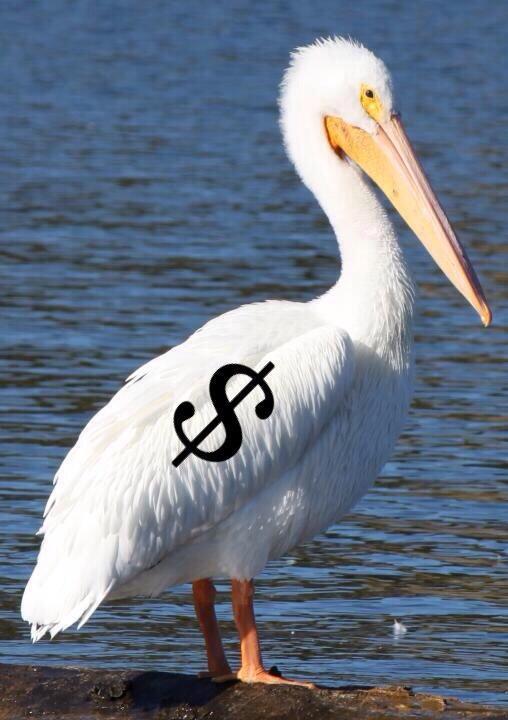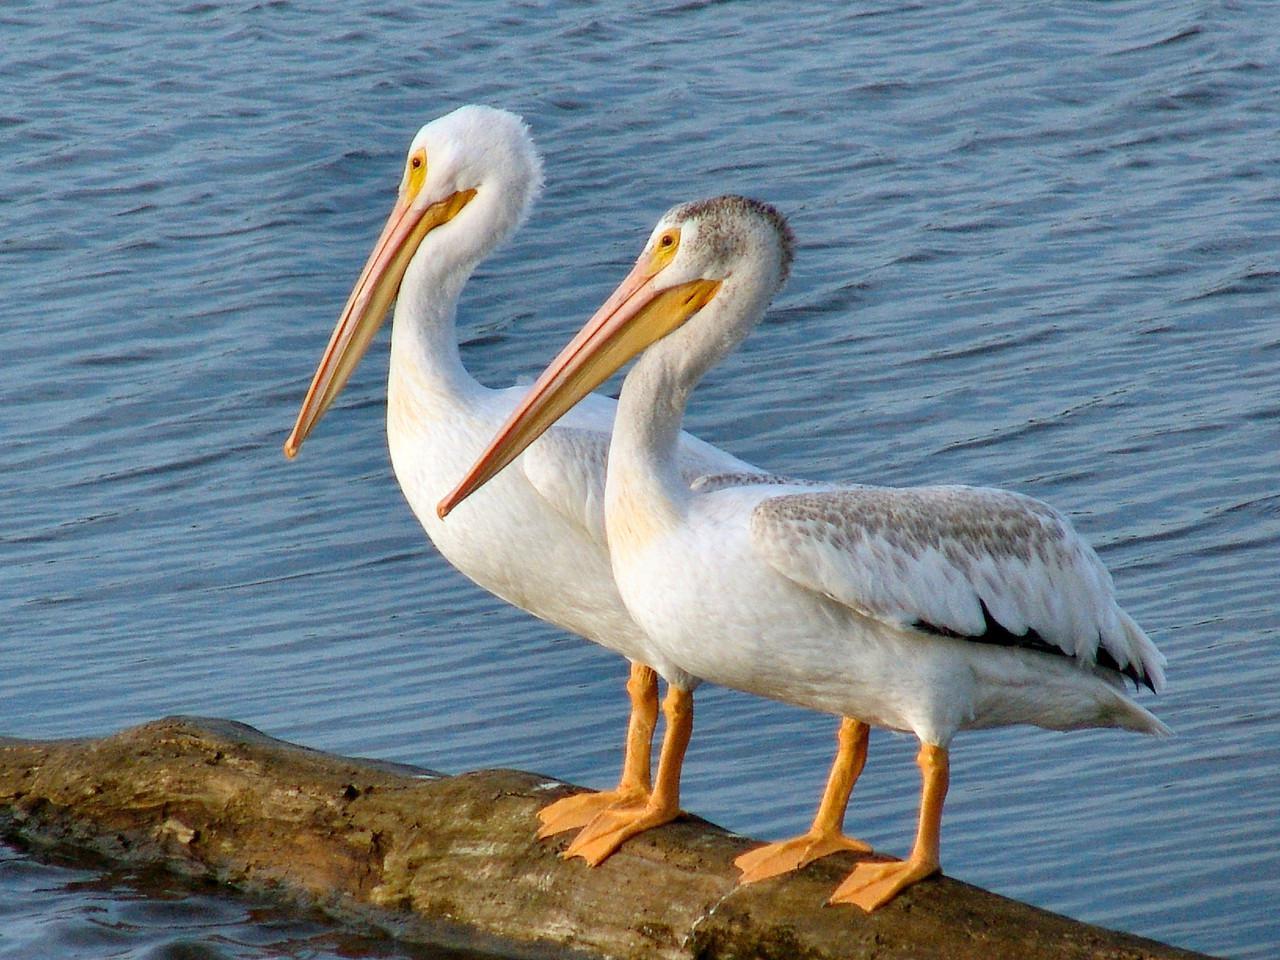The first image is the image on the left, the second image is the image on the right. Assess this claim about the two images: "In one of the image two birds are on a log facing left.". Correct or not? Answer yes or no. Yes. The first image is the image on the left, the second image is the image on the right. Considering the images on both sides, is "One of the pelicans has a fish in its mouth." valid? Answer yes or no. No. 